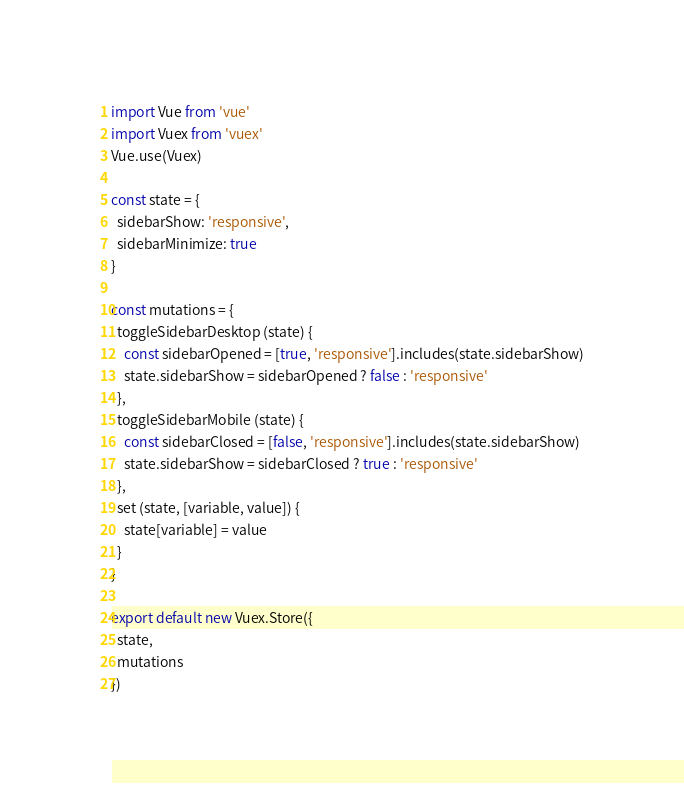Convert code to text. <code><loc_0><loc_0><loc_500><loc_500><_JavaScript_>import Vue from 'vue'
import Vuex from 'vuex'
Vue.use(Vuex)

const state = {
  sidebarShow: 'responsive',
  sidebarMinimize: true
}

const mutations = {
  toggleSidebarDesktop (state) {
    const sidebarOpened = [true, 'responsive'].includes(state.sidebarShow)
    state.sidebarShow = sidebarOpened ? false : 'responsive'
  },
  toggleSidebarMobile (state) {
    const sidebarClosed = [false, 'responsive'].includes(state.sidebarShow)
    state.sidebarShow = sidebarClosed ? true : 'responsive'
  },
  set (state, [variable, value]) {
    state[variable] = value
  }
}

export default new Vuex.Store({
  state,
  mutations
})</code> 